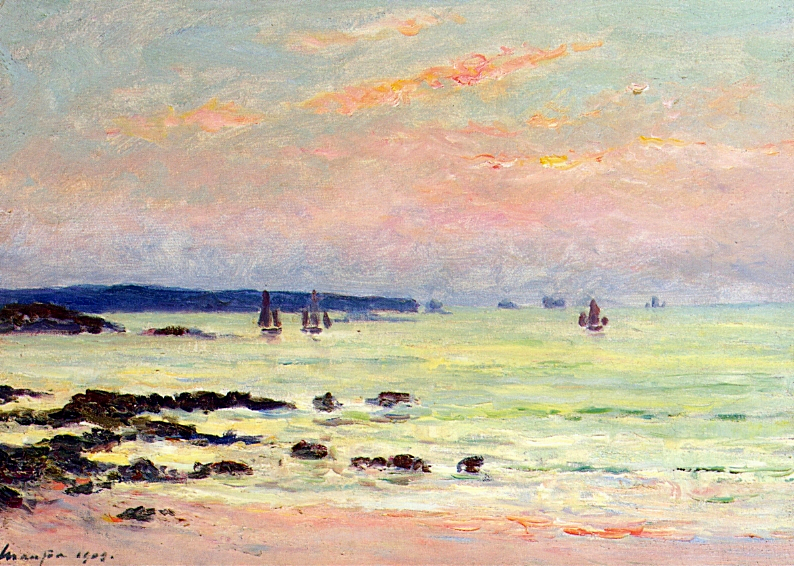What is this photo about? This image features a vibrant seascape painting, likely crafted in the impressionist style, which is known for its focus on light and color. The canvas is awash with a variety of blues and greens, which create the calm yet textured depiction of the sea. Sails in the distance suggest the presence of boats, while the warm hues of the sunset or sunrise sky invoke feelings of serenity. The way the light plays across the water and clouds demonstrates the artist's skill in capturing ephemeral moments, offering viewers a snapshot of tranquil maritime beauty. 